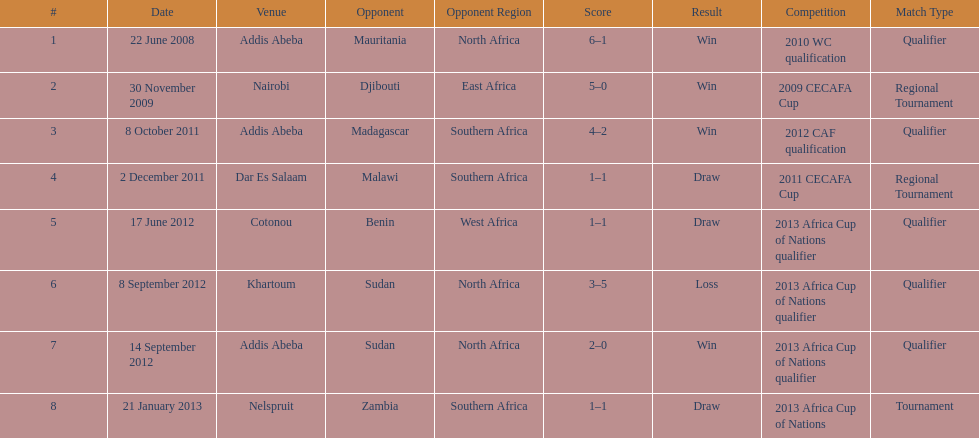Number of different teams listed on the chart 7. 